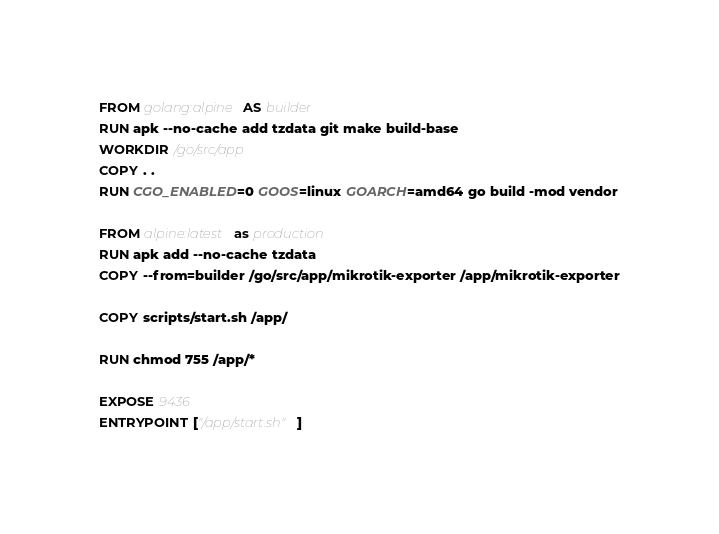<code> <loc_0><loc_0><loc_500><loc_500><_Dockerfile_>FROM golang:alpine AS builder
RUN apk --no-cache add tzdata git make build-base
WORKDIR /go/src/app
COPY . .
RUN CGO_ENABLED=0 GOOS=linux GOARCH=amd64 go build -mod vendor

FROM alpine:latest as production
RUN apk add --no-cache tzdata
COPY --from=builder /go/src/app/mikrotik-exporter /app/mikrotik-exporter

COPY scripts/start.sh /app/

RUN chmod 755 /app/*

EXPOSE 9436
ENTRYPOINT ["/app/start.sh"]
</code> 